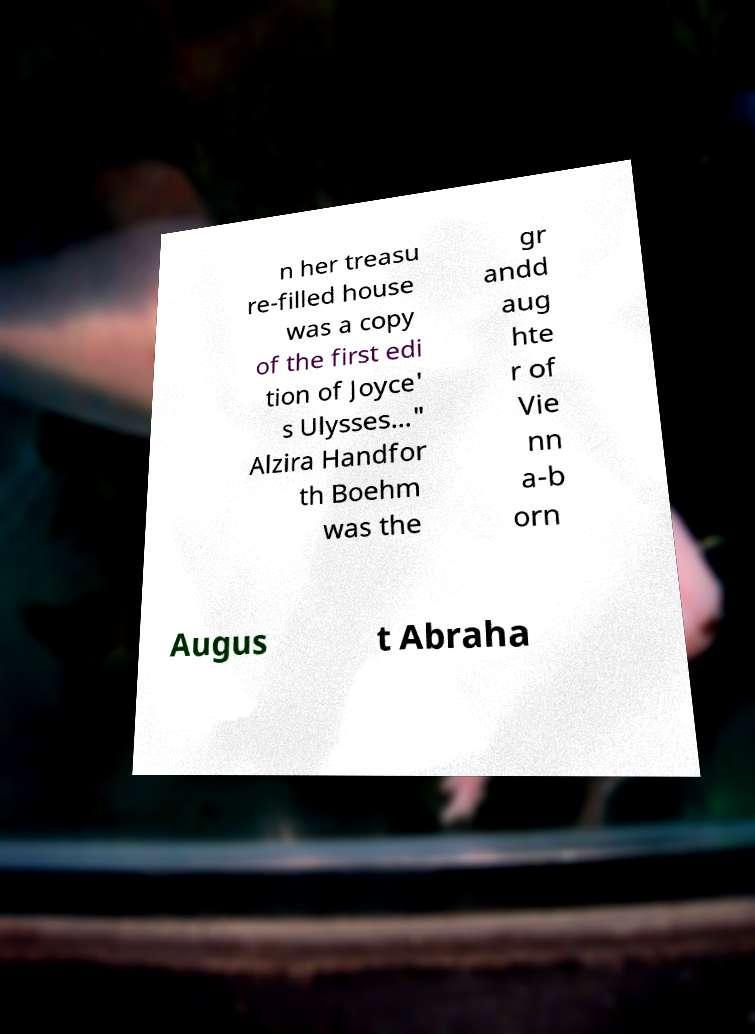There's text embedded in this image that I need extracted. Can you transcribe it verbatim? n her treasu re-filled house was a copy of the first edi tion of Joyce' s Ulysses..." Alzira Handfor th Boehm was the gr andd aug hte r of Vie nn a-b orn Augus t Abraha 